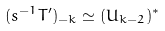Convert formula to latex. <formula><loc_0><loc_0><loc_500><loc_500>( s ^ { - 1 } T ^ { \prime } ) _ { - k } \simeq ( U _ { k - 2 } ) ^ { * }</formula> 